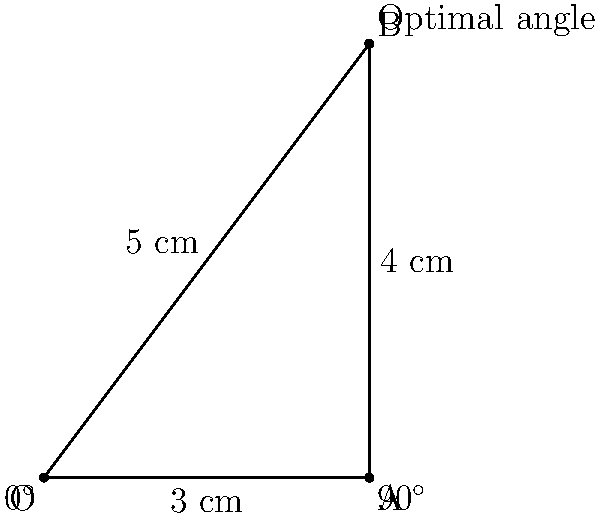As a paramedic, you need to administer an intramuscular injection to a soldier. The optimal injection angle is represented by the hypotenuse of a right triangle. If the adjacent side is 3 cm and the opposite side is 4 cm, what is the optimal angle for the injection in degrees? To find the optimal angle for the injection, we need to use trigonometry:

1. We have a right triangle with the following sides:
   - Adjacent side: 3 cm
   - Opposite side: 4 cm
   - Hypotenuse: unknown (but not needed for this calculation)

2. To find the angle, we'll use the arctangent function (inverse tangent or $\tan^{-1}$):

   $\theta = \tan^{-1}(\frac{\text{opposite}}{\text{adjacent}})$

3. Substituting our values:

   $\theta = \tan^{-1}(\frac{4}{3})$

4. Calculate:
   $\theta \approx 53.13010235415598^\circ$

5. Round to the nearest degree:
   $\theta \approx 53^\circ$

Therefore, the optimal angle for administering the intramuscular injection is approximately 53 degrees.
Answer: $53^\circ$ 